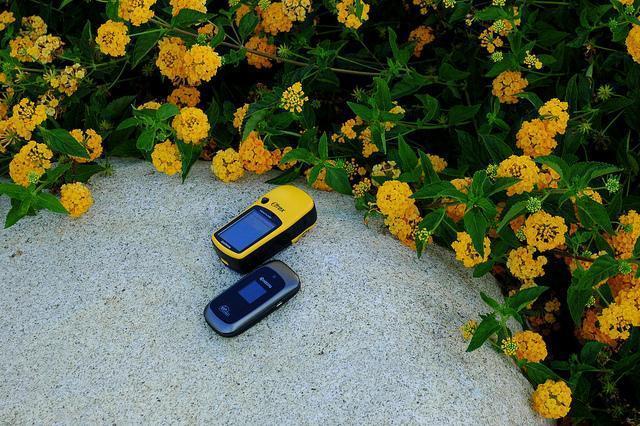How many cell phones can you see?
Give a very brief answer. 2. How many people are facing the camera?
Give a very brief answer. 0. 